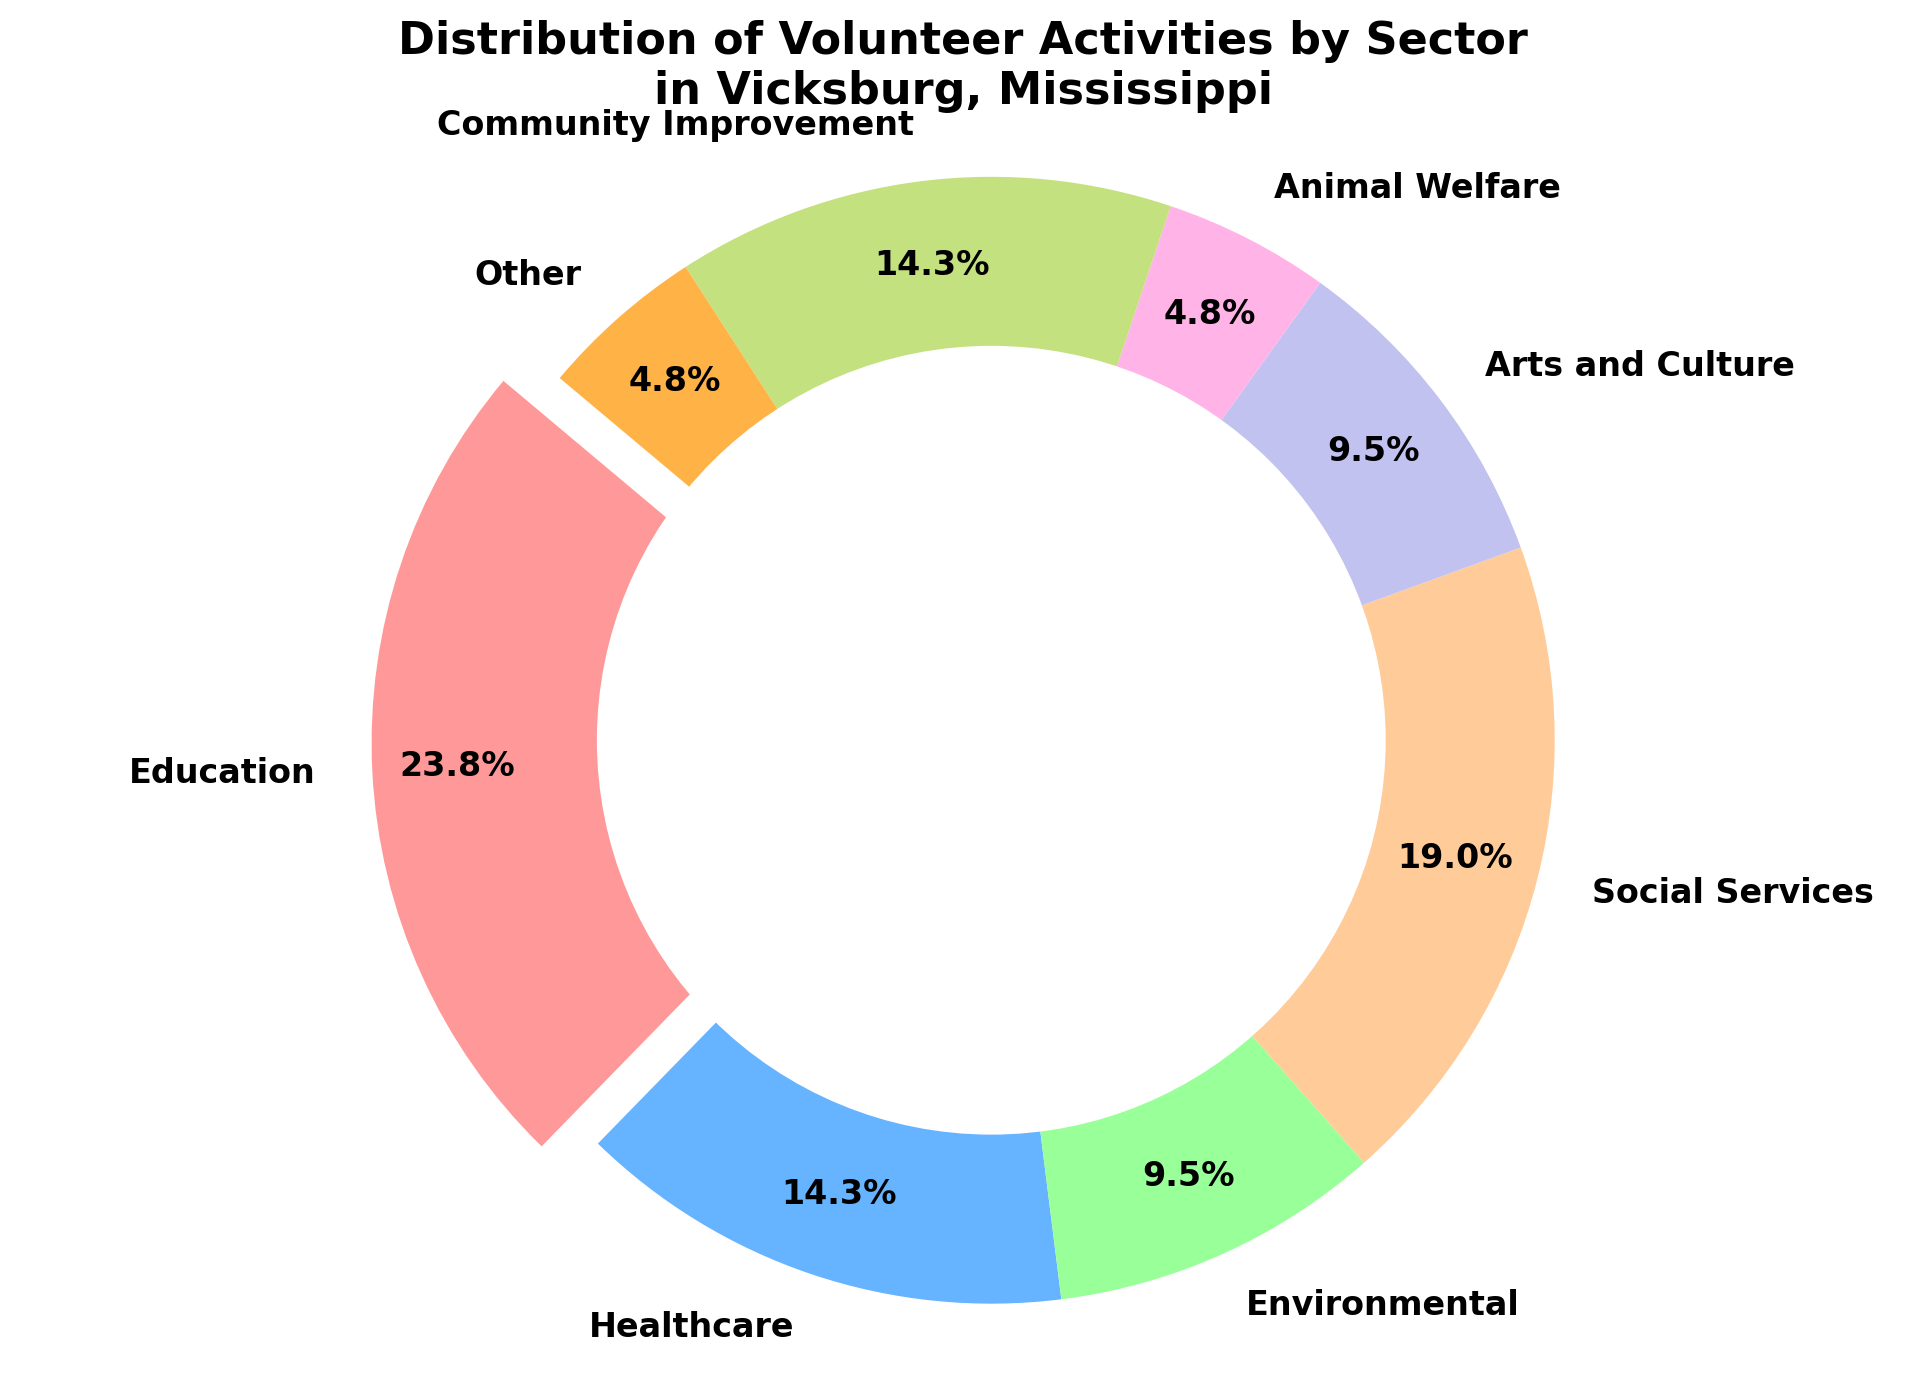What sector has the highest percentage of volunteer activities? The sector with the highest percentage can be identified by locating the largest wedge. From the figure, the section that is exploded is the largest one, which represents Education.
Answer: Education What is the combined percentage of volunteer activities in the Healthcare and Community Improvement sectors? The combined percentage can be calculated by adding the percentages of both sectors. Healthcare is 15% and Community Improvement is also 15%. Therefore, 15% + 15% = 30%.
Answer: 30% Which sectors have an equal percentage of volunteer activities? By examining the figure, we can see that both the Animal Welfare and the Other sectors have an equal slice size, which is 5%. Similarly, Healthcare and Community Improvement both have 15%.
Answer: Animal Welfare and Other; Healthcare and Community Improvement How much greater is the percentage of volunteer activities in Education compared to Social Services? The percentage for Education is 25%, and for Social Services, it is 20%. The difference is calculated as 25% - 20% = 5%.
Answer: 5% What is the least common sector for volunteer activities? The least common sector can be identified by locating the smallest wedge in the pie chart. In the figure, the smallest sections are Animal Welfare and Other, both at 5%.
Answer: Animal Welfare and Other What is the average percentage of volunteer activities across all sectors? To find the average, sum all the percentages and divide by the number of sectors. The sum is 25% + 15% + 10% + 20% + 10% + 5% + 15% + 5% = 105%. There are 8 sectors, so the average is 105% / 8 = 13.125%.
Answer: 13.125% Which sector is represented by the green-colored wedge in the pie chart? By identifying the visual color correspondence, the green-colored wedge represents the Environmental sector.
Answer: Environmental How does the percentage of volunteer activities in Arts and Culture compare to Environmental? Both sectors have the same percentage of 10%, as indicated by the equal size of their wedges.
Answer: They are equal If the categories of Animal Welfare and Other were combined, what would be their total percentage? Combine the percentages of Animal Welfare and Other. Both are 5%, so 5% + 5% = 10%.
Answer: 10% 